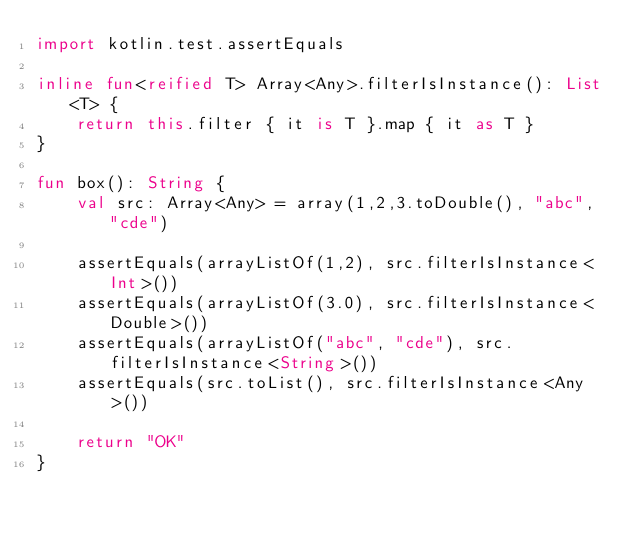Convert code to text. <code><loc_0><loc_0><loc_500><loc_500><_Kotlin_>import kotlin.test.assertEquals

inline fun<reified T> Array<Any>.filterIsInstance(): List<T> {
    return this.filter { it is T }.map { it as T }
}

fun box(): String {
    val src: Array<Any> = array(1,2,3.toDouble(), "abc", "cde")

    assertEquals(arrayListOf(1,2), src.filterIsInstance<Int>())
    assertEquals(arrayListOf(3.0), src.filterIsInstance<Double>())
    assertEquals(arrayListOf("abc", "cde"), src.filterIsInstance<String>())
    assertEquals(src.toList(), src.filterIsInstance<Any>())

    return "OK"
}
</code> 